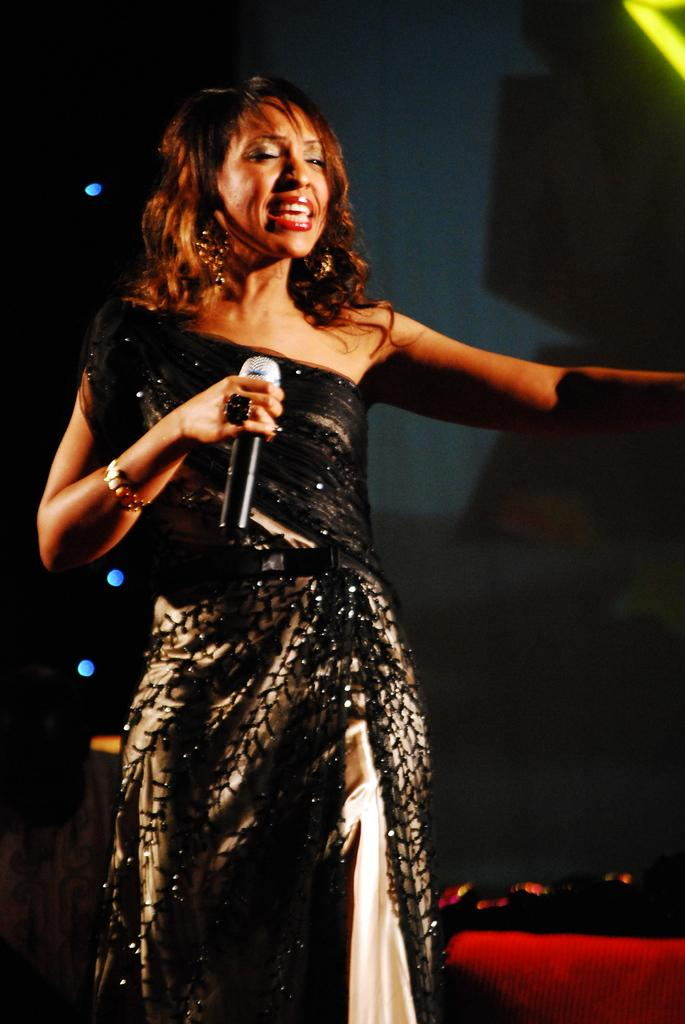Who is the main subject in the image? There is a lady in the image. What is the lady doing in the image? The lady is standing and holding a mic. What can be seen in the background of the image? There are lights and a wall in the background of the image. Is there any furniture visible in the image? Yes, there is a chair at the bottom of the image. What type of fang can be seen in the lady's mouth in the image? There is no fang visible in the lady's mouth in the image. What flavor of soda is the lady holding in the image? The lady is holding a mic, not a soda, in the image. 